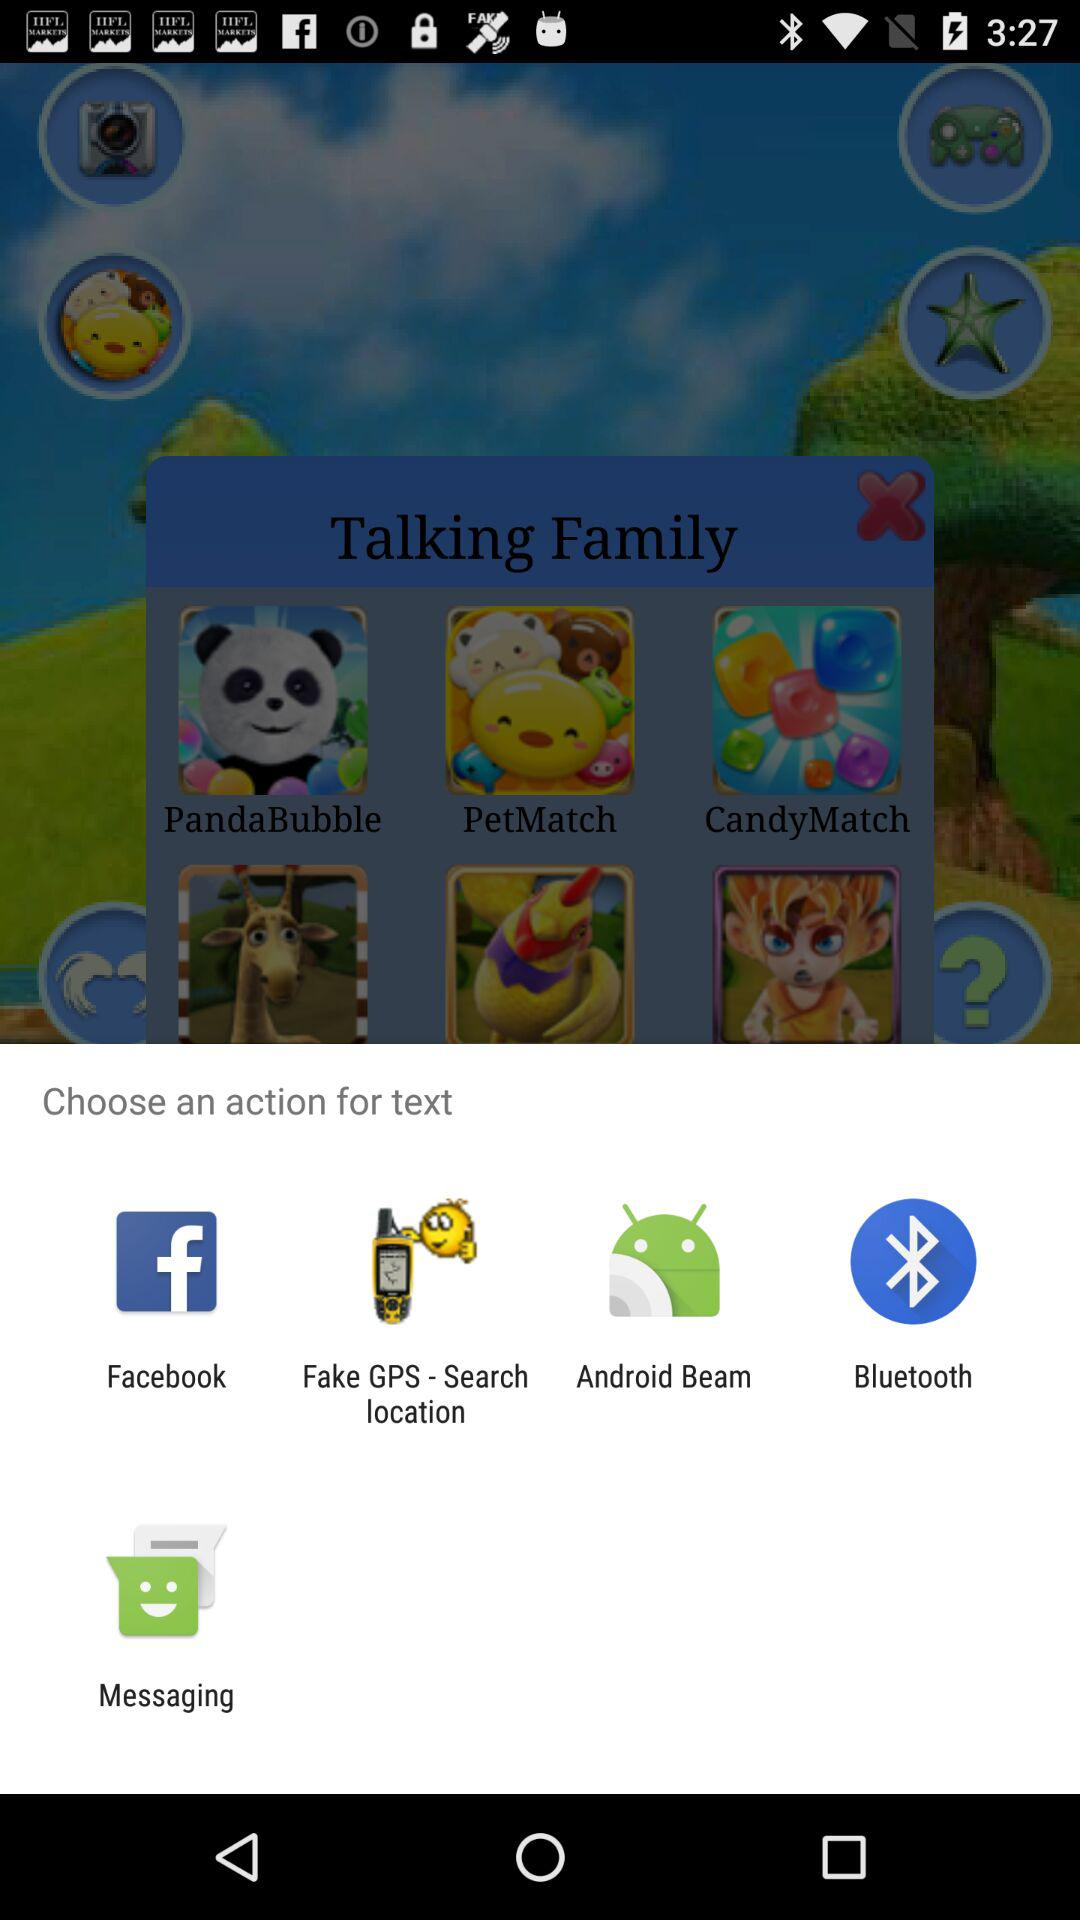Which application can I use to text? You can use "Facebook", "Fake GPS - Search location", "Android Beam", "Bluetooth" and "Messaging". 